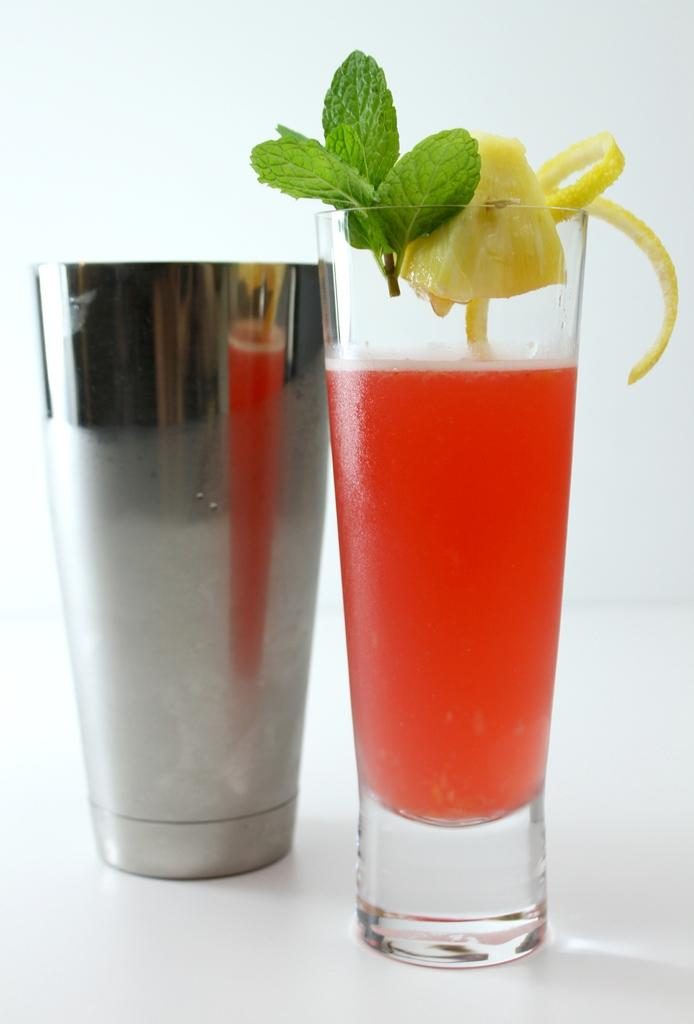What objects are on the floor in the image? There are two glasses on the floor in the image. What can be found inside the glasses? There is a drink in the image. What type of natural elements are present in the image? There are leaves and a fruit in the image. What color is the background of the image? The background of the image is white in color. What type of alarm is ringing in the image? There is no alarm present in the image. On what type of furniture is the fruit placed in the image? The provided facts do not mention any furniture in the image, so we cannot determine where the fruit is placed. 